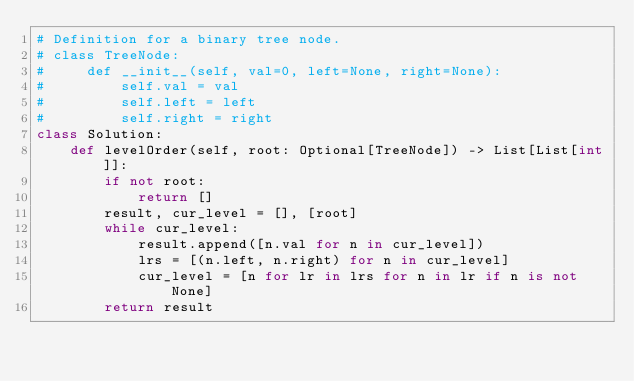Convert code to text. <code><loc_0><loc_0><loc_500><loc_500><_Python_># Definition for a binary tree node.
# class TreeNode:
#     def __init__(self, val=0, left=None, right=None):
#         self.val = val
#         self.left = left
#         self.right = right
class Solution:
    def levelOrder(self, root: Optional[TreeNode]) -> List[List[int]]:
        if not root:
            return []
        result, cur_level = [], [root]
        while cur_level:
            result.append([n.val for n in cur_level])
            lrs = [(n.left, n.right) for n in cur_level]
            cur_level = [n for lr in lrs for n in lr if n is not None]
        return result
</code> 